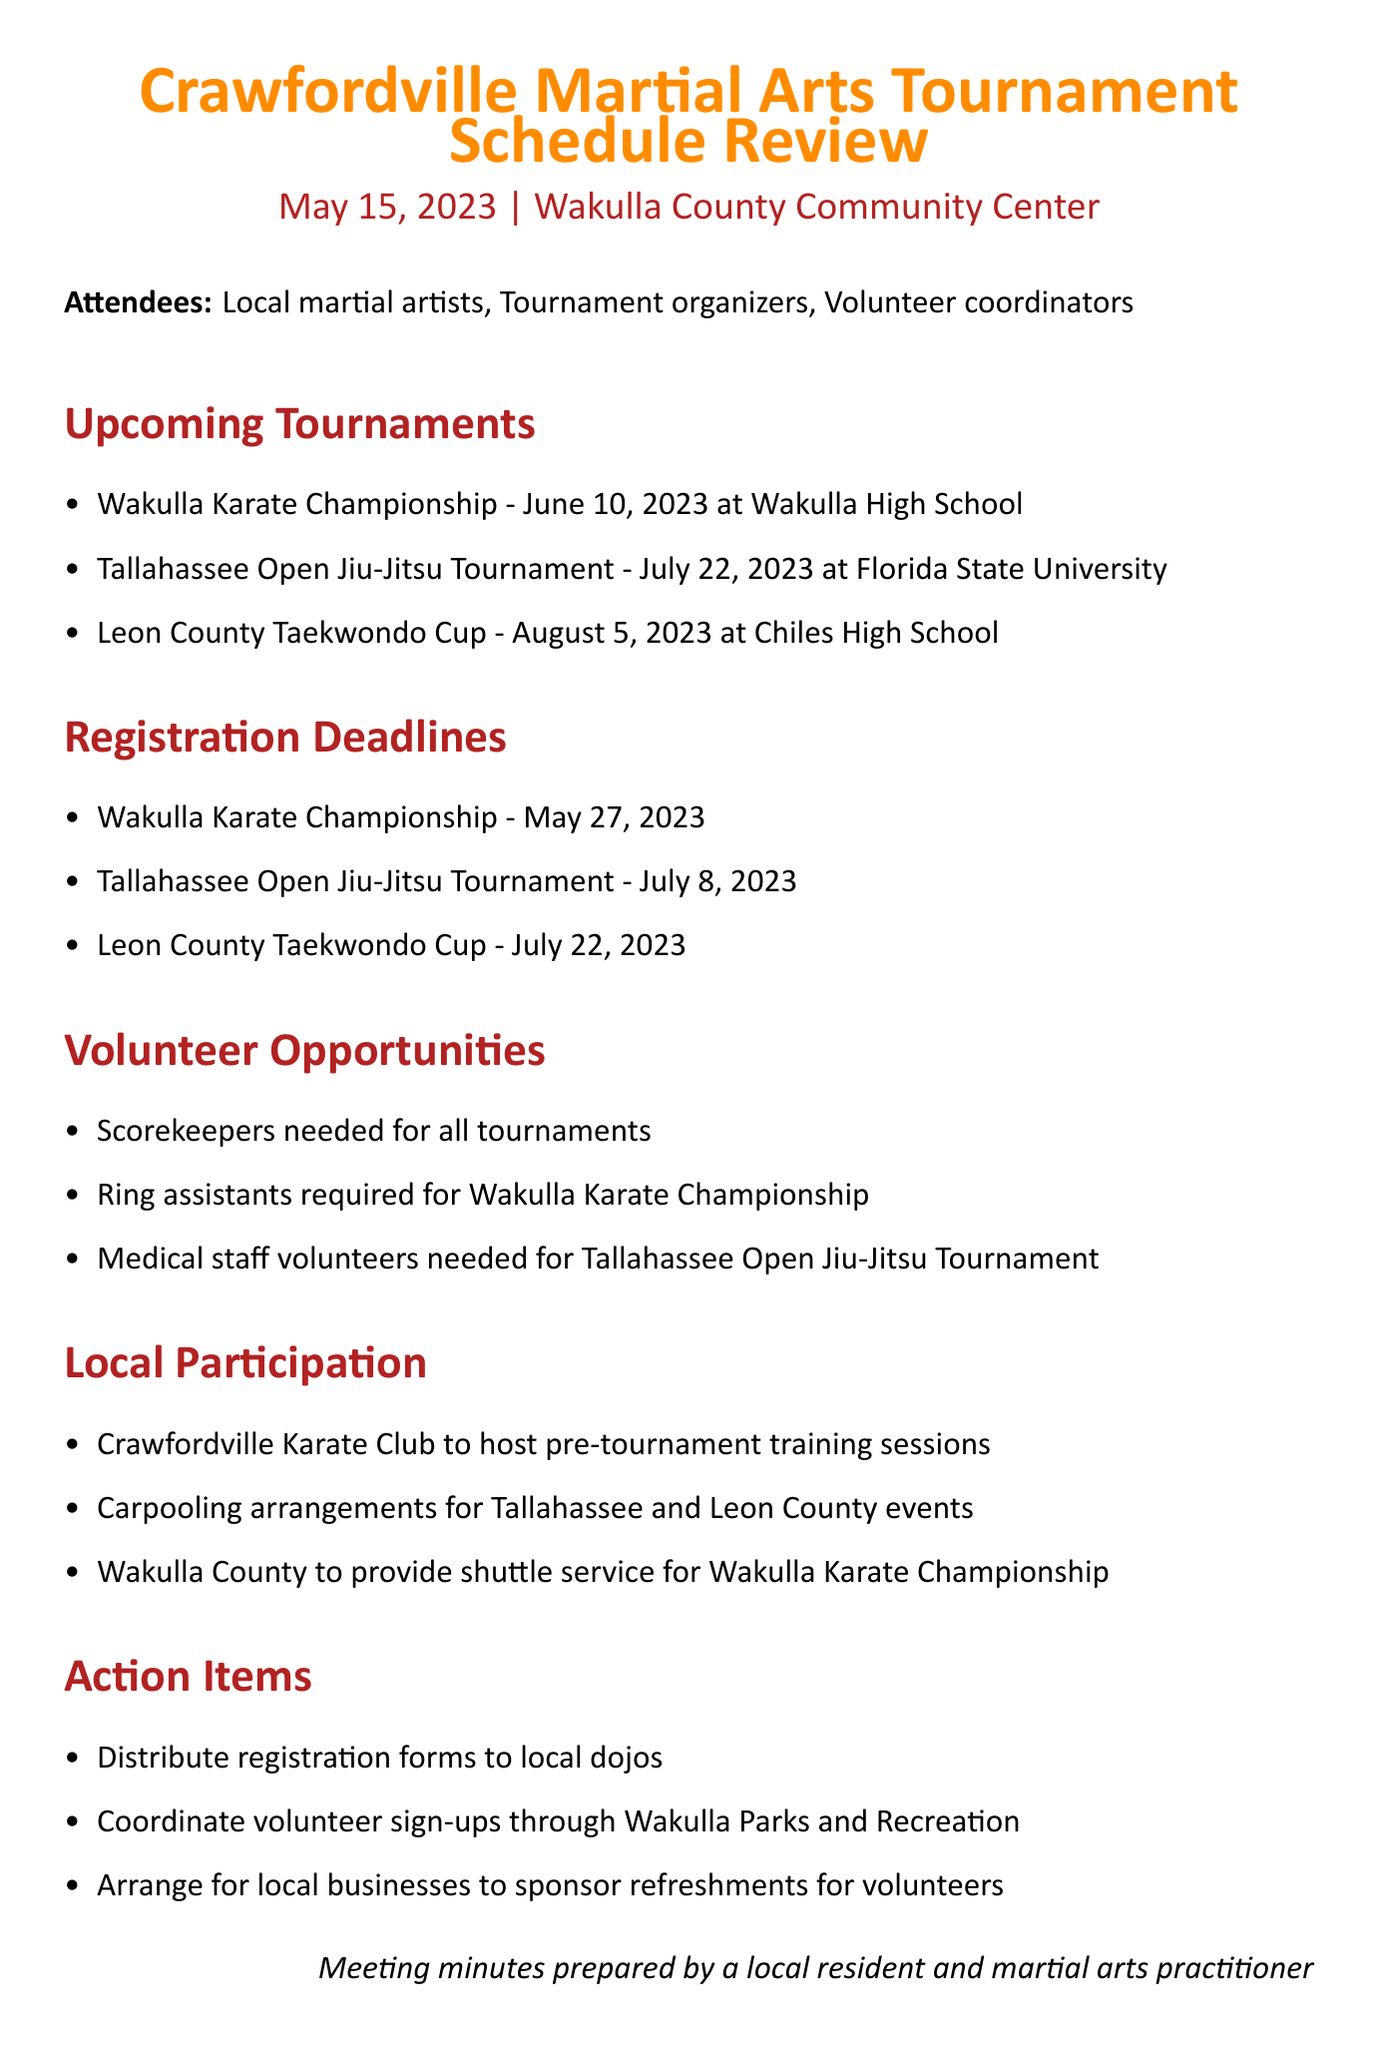What is the date of the Wakulla Karate Championship? The document states that the Wakulla Karate Championship is scheduled for June 10, 2023.
Answer: June 10, 2023 What is the registration deadline for the Tallahassee Open Jiu-Jitsu Tournament? According to the document, the registration deadline for this tournament is July 8, 2023.
Answer: July 8, 2023 Which location is hosting the Leon County Taekwondo Cup? The document specifies that the Leon County Taekwondo Cup will take place at Chiles High School.
Answer: Chiles High School What volunteer position is required for all tournaments? The document mentions that scorekeepers are needed for all tournaments.
Answer: Scorekeepers What opportunity is available for the Wakulla Karate Championship? The document details that ring assistants are required for the Wakulla Karate Championship.
Answer: Ring assistants Where will the Crawfordville Karate Club host training sessions? The document states that the Crawfordville Karate Club will host pre-tournament training sessions.
Answer: Pre-tournament training sessions What action item involves local dojos? The document outlines that registration forms need to be distributed to local dojos.
Answer: Distribute registration forms What is the transportation arrangement for the Tallahassee and Leon County events? The document mentions carpooling arrangements for these events.
Answer: Carpooling arrangements 